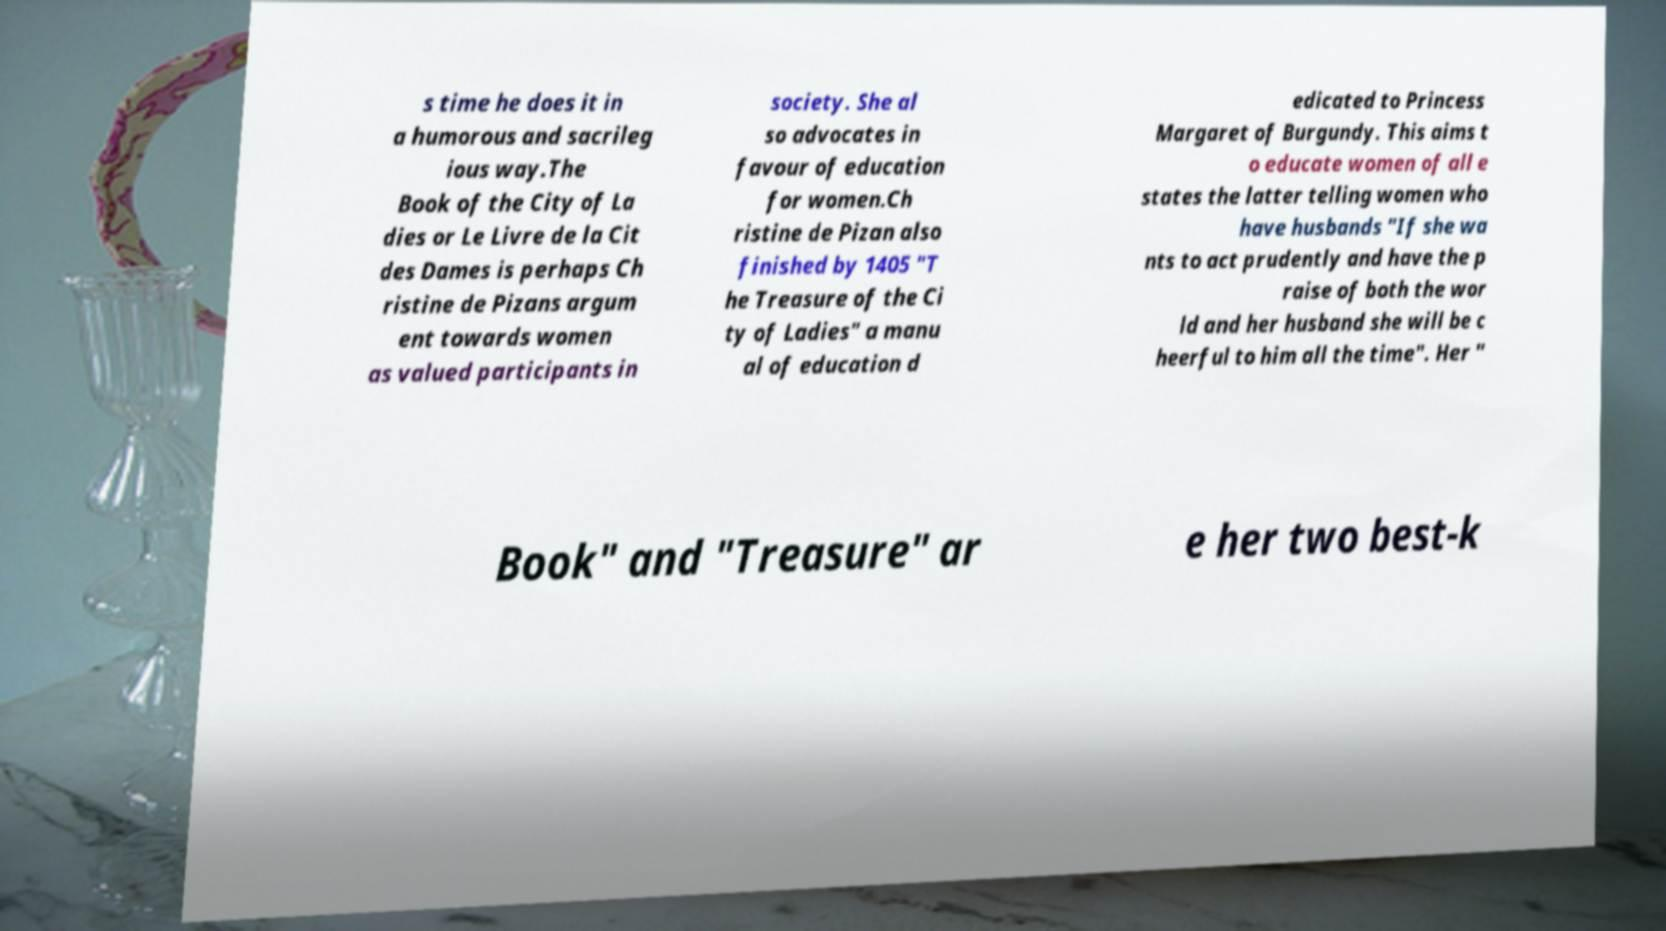There's text embedded in this image that I need extracted. Can you transcribe it verbatim? s time he does it in a humorous and sacrileg ious way.The Book of the City of La dies or Le Livre de la Cit des Dames is perhaps Ch ristine de Pizans argum ent towards women as valued participants in society. She al so advocates in favour of education for women.Ch ristine de Pizan also finished by 1405 "T he Treasure of the Ci ty of Ladies" a manu al of education d edicated to Princess Margaret of Burgundy. This aims t o educate women of all e states the latter telling women who have husbands "If she wa nts to act prudently and have the p raise of both the wor ld and her husband she will be c heerful to him all the time". Her " Book" and "Treasure" ar e her two best-k 